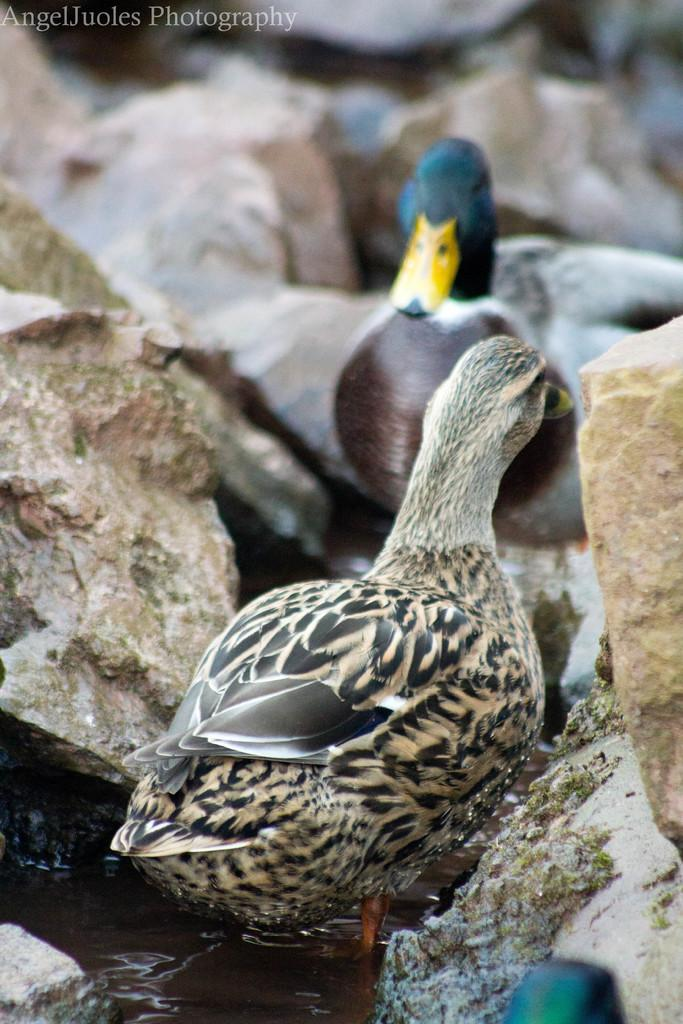What type of animals can be seen in the image? Birds can be seen in the image. What is the primary element in which the birds are situated? The birds are situated in water. What other objects are present in the image? There are rocks visible in the image. Is there any text or marking on the image? Yes, there is a watermark at the top of the image. What type of operation is being performed on the grape in the image? There is no grape present in the image, and no operation is being performed. Can you see the elbow of any person in the image? There are no people visible in the image, so there are no elbows to be seen. 